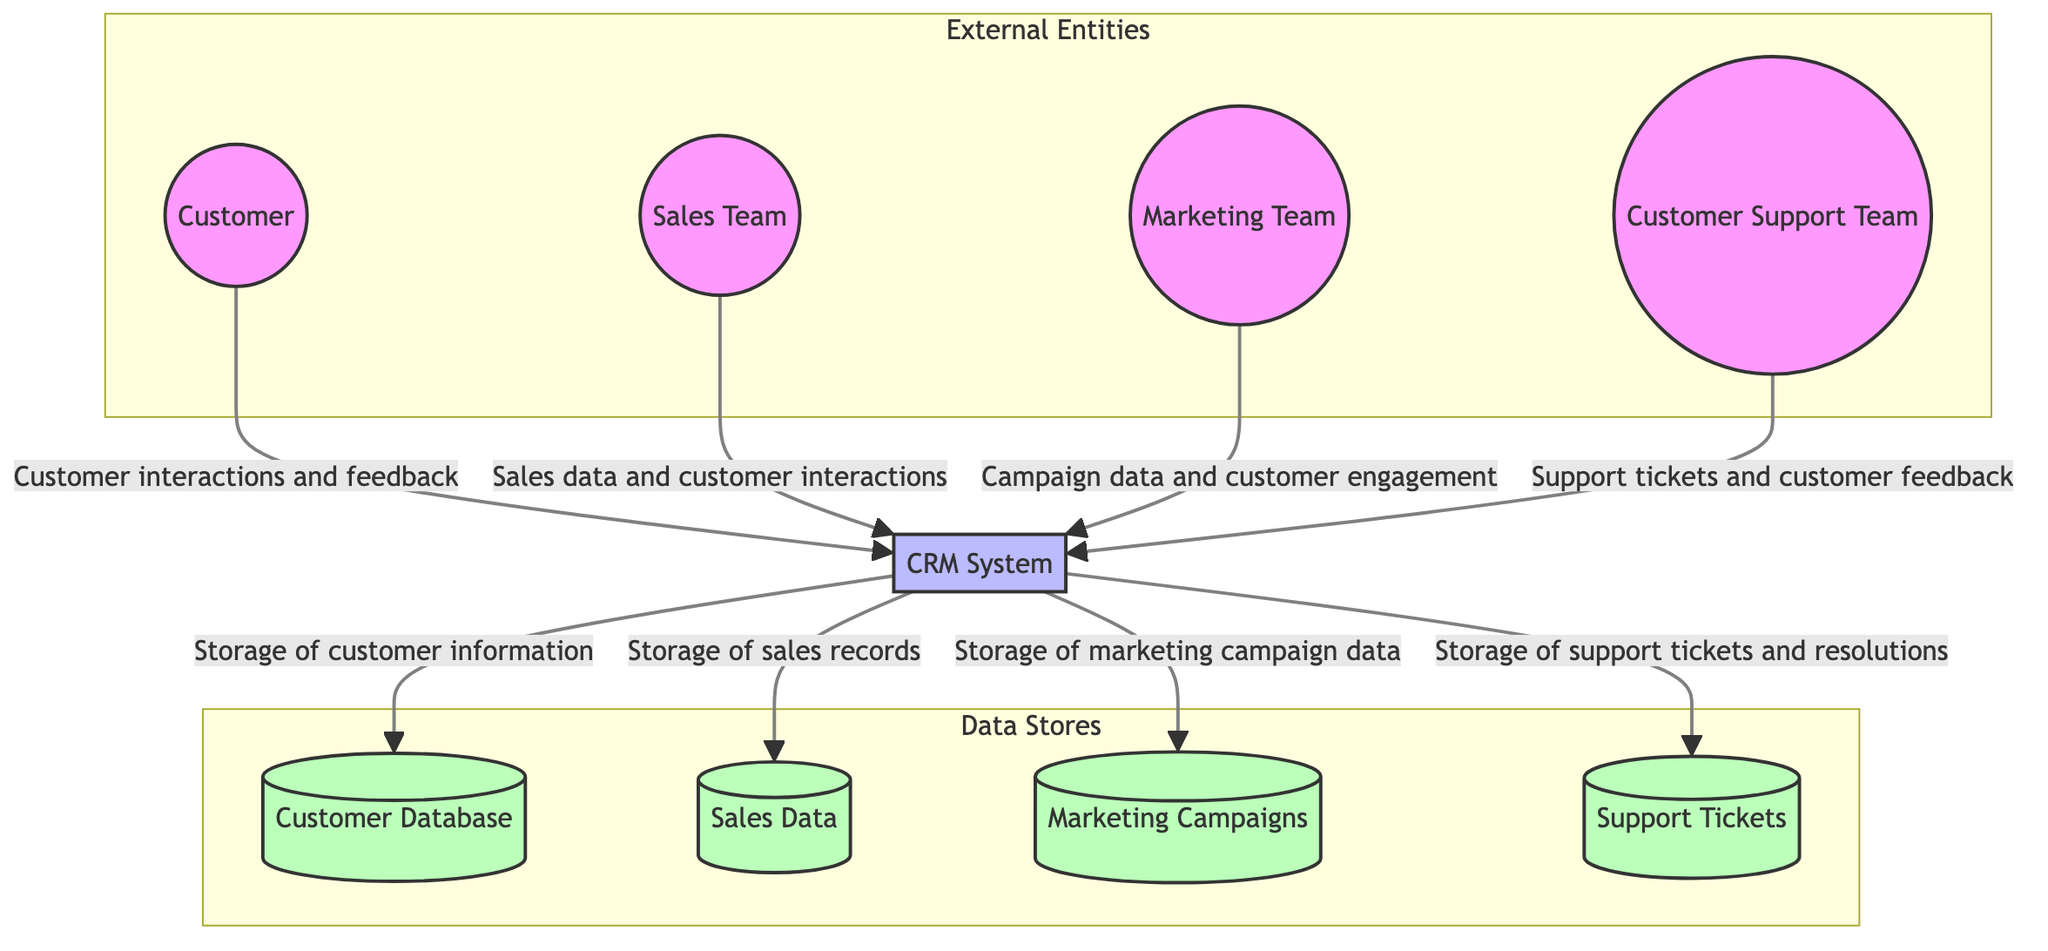What is the main process represented in the diagram? The main process in the diagram is the CRM System, which is central to managing customer relationships and data.
Answer: CRM System How many external entities are present in the diagram? There are four external entities represented: Customer, Sales Team, Marketing Team, and Customer Support Team. Counting them gives a total of four.
Answer: 4 Which external entity provides customer interactions and feedback to the CRM system? The Customer is the external entity that provides interactions and feedback to the CRM system as indicated by the directed arrow.
Answer: Customer What type of data does the Sales Team provide to the CRM system? The Sales Team provides sales data and customer interactions to the CRM system, as described in the directed data flow.
Answer: Sales data and customer interactions How many data stores are connected to the CRM System? The diagram indicates that there are four data stores, specifically the Customer Database, Sales Data, Marketing Campaigns, and Support Tickets, all of which receive data from the CRM System.
Answer: 4 What is the purpose of the Customer Database? The Customer Database is used for the storage of customer information, as defined by the data flow from the CRM System to this data store.
Answer: Storage of customer information Which team is responsible for managing marketing campaigns? The Marketing Team is responsible for managing marketing campaigns, as shown in the data flow from this team to the CRM System.
Answer: Marketing Team What are the types of data stored in the Sales Data database? The Sales Data database stores sales records and transactional data, as indicated by the description accompanying the data flow from the CRM System.
Answer: Sales records Which external entity handles customer support tickets? The Customer Support Team handles customer support tickets, which are sent to the CRM System as shown in the diagram.
Answer: Customer Support Team 